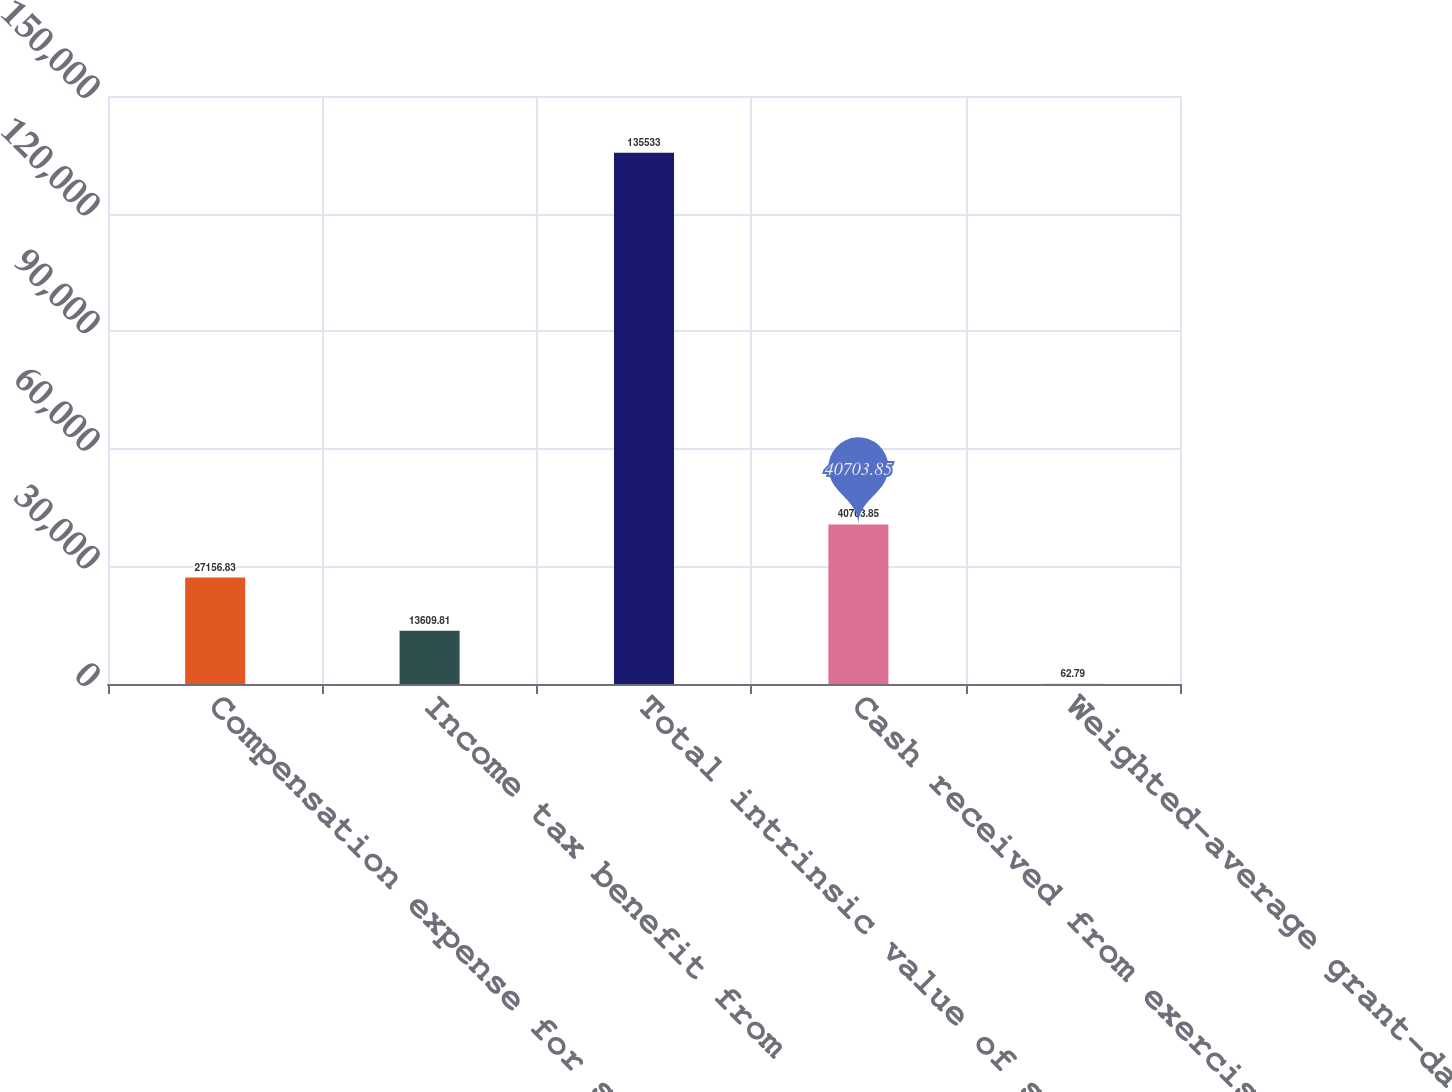Convert chart to OTSL. <chart><loc_0><loc_0><loc_500><loc_500><bar_chart><fcel>Compensation expense for stock<fcel>Income tax benefit from<fcel>Total intrinsic value of stock<fcel>Cash received from exercise of<fcel>Weighted-average grant-date<nl><fcel>27156.8<fcel>13609.8<fcel>135533<fcel>40703.8<fcel>62.79<nl></chart> 